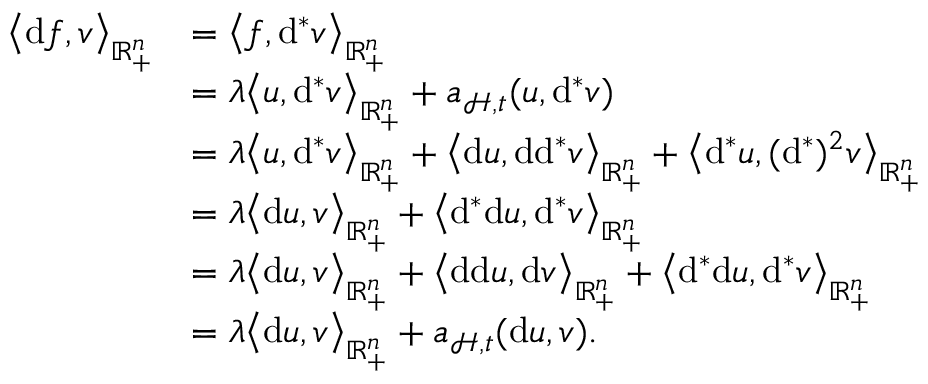Convert formula to latex. <formula><loc_0><loc_0><loc_500><loc_500>\begin{array} { r l } { \left \langle d f , v \right \rangle _ { \mathbb { R } _ { + } ^ { n } } } & { = \left \langle f , d ^ { \ast } v \right \rangle _ { \mathbb { R } _ { + } ^ { n } } } \\ & { = \lambda \left \langle u , d ^ { \ast } v \right \rangle _ { \mathbb { R } _ { + } ^ { n } } + \mathfrak { a } _ { \mathcal { H } , \mathfrak { t } } ( u , d ^ { \ast } v ) } \\ & { = \lambda \left \langle u , d ^ { \ast } v \right \rangle _ { \mathbb { R } _ { + } ^ { n } } + \left \langle d u , d d ^ { \ast } v \right \rangle _ { \mathbb { R } _ { + } ^ { n } } + \left \langle d ^ { \ast } u , ( d ^ { \ast } ) ^ { 2 } v \right \rangle _ { \mathbb { R } _ { + } ^ { n } } } \\ & { = \lambda \left \langle d u , v \right \rangle _ { \mathbb { R } _ { + } ^ { n } } + \left \langle d ^ { \ast } d u , d ^ { \ast } v \right \rangle _ { \mathbb { R } _ { + } ^ { n } } } \\ & { = \lambda \left \langle d u , v \right \rangle _ { \mathbb { R } _ { + } ^ { n } } + \left \langle d d u , d v \right \rangle _ { \mathbb { R } _ { + } ^ { n } } + \left \langle d ^ { \ast } d u , d ^ { \ast } v \right \rangle _ { \mathbb { R } _ { + } ^ { n } } } \\ & { = \lambda \left \langle d u , v \right \rangle _ { \mathbb { R } _ { + } ^ { n } } + \mathfrak { a } _ { \mathcal { H } , \mathfrak { t } } ( d u , v ) . } \end{array}</formula> 